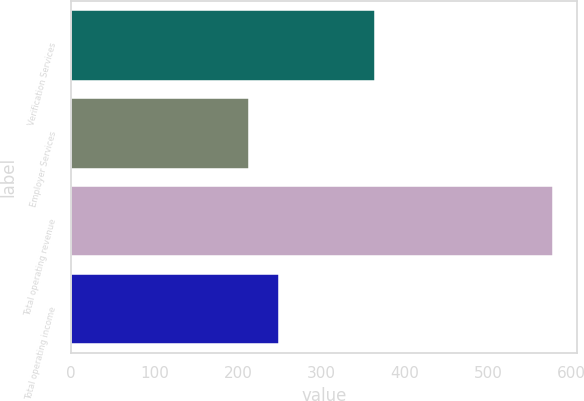<chart> <loc_0><loc_0><loc_500><loc_500><bar_chart><fcel>Verification Services<fcel>Employer Services<fcel>Total operating revenue<fcel>Total operating income<nl><fcel>364.4<fcel>213.3<fcel>577.7<fcel>249.74<nl></chart> 